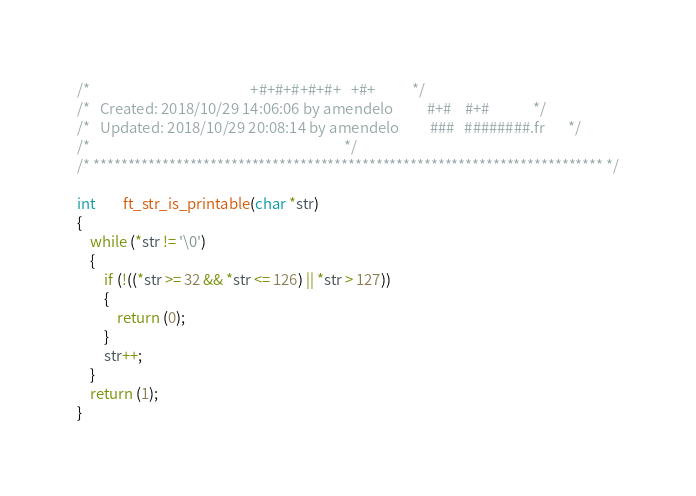<code> <loc_0><loc_0><loc_500><loc_500><_C_>/*                                                +#+#+#+#+#+   +#+           */
/*   Created: 2018/10/29 14:06:06 by amendelo          #+#    #+#             */
/*   Updated: 2018/10/29 20:08:14 by amendelo         ###   ########.fr       */
/*                                                                            */
/* ************************************************************************** */

int		ft_str_is_printable(char *str)
{
	while (*str != '\0')
	{
		if (!((*str >= 32 && *str <= 126) || *str > 127))
		{
			return (0);
		}
		str++;
	}
	return (1);
}
</code> 